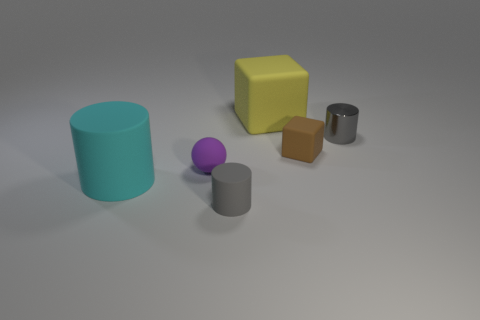What is the color of the smallest object in the image? The smallest object in the image is the purple sphere. 